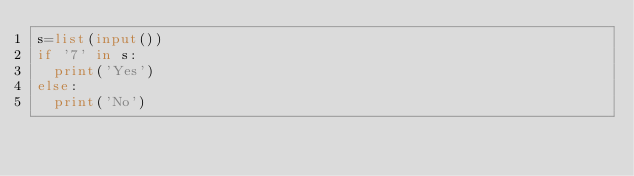<code> <loc_0><loc_0><loc_500><loc_500><_Python_>s=list(input())
if '7' in s:
  print('Yes')
else:
  print('No')</code> 